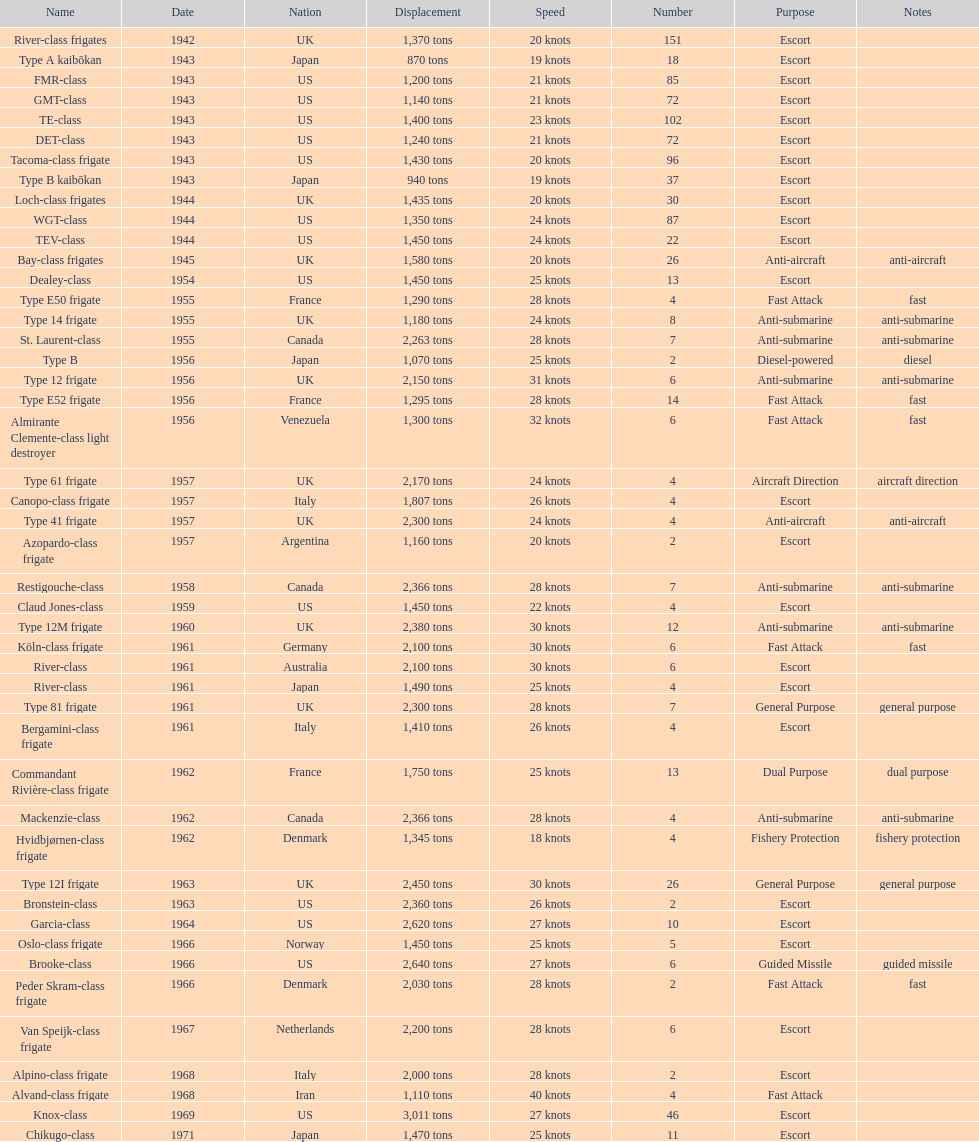What is the top speed? 40 knots. Give me the full table as a dictionary. {'header': ['Name', 'Date', 'Nation', 'Displacement', 'Speed', 'Number', 'Purpose', 'Notes'], 'rows': [['River-class frigates', '1942', 'UK', '1,370 tons', '20 knots', '151', 'Escort', ''], ['Type A kaibōkan', '1943', 'Japan', '870 tons', '19 knots', '18', 'Escort', ''], ['FMR-class', '1943', 'US', '1,200 tons', '21 knots', '85', 'Escort', ''], ['GMT-class', '1943', 'US', '1,140 tons', '21 knots', '72', 'Escort', ''], ['TE-class', '1943', 'US', '1,400 tons', '23 knots', '102', 'Escort', ''], ['DET-class', '1943', 'US', '1,240 tons', '21 knots', '72', 'Escort', ''], ['Tacoma-class frigate', '1943', 'US', '1,430 tons', '20 knots', '96', 'Escort', ''], ['Type B kaibōkan', '1943', 'Japan', '940 tons', '19 knots', '37', 'Escort', ''], ['Loch-class frigates', '1944', 'UK', '1,435 tons', '20 knots', '30', 'Escort', ''], ['WGT-class', '1944', 'US', '1,350 tons', '24 knots', '87', 'Escort', ''], ['TEV-class', '1944', 'US', '1,450 tons', '24 knots', '22', 'Escort', ''], ['Bay-class frigates', '1945', 'UK', '1,580 tons', '20 knots', '26', 'Anti-aircraft', 'anti-aircraft'], ['Dealey-class', '1954', 'US', '1,450 tons', '25 knots', '13', 'Escort', ''], ['Type E50 frigate', '1955', 'France', '1,290 tons', '28 knots', '4', 'Fast Attack', 'fast'], ['Type 14 frigate', '1955', 'UK', '1,180 tons', '24 knots', '8', 'Anti-submarine', 'anti-submarine'], ['St. Laurent-class', '1955', 'Canada', '2,263 tons', '28 knots', '7', 'Anti-submarine', 'anti-submarine'], ['Type B', '1956', 'Japan', '1,070 tons', '25 knots', '2', 'Diesel-powered', 'diesel'], ['Type 12 frigate', '1956', 'UK', '2,150 tons', '31 knots', '6', 'Anti-submarine', 'anti-submarine'], ['Type E52 frigate', '1956', 'France', '1,295 tons', '28 knots', '14', 'Fast Attack', 'fast'], ['Almirante Clemente-class light destroyer', '1956', 'Venezuela', '1,300 tons', '32 knots', '6', 'Fast Attack', 'fast'], ['Type 61 frigate', '1957', 'UK', '2,170 tons', '24 knots', '4', 'Aircraft Direction', 'aircraft direction'], ['Canopo-class frigate', '1957', 'Italy', '1,807 tons', '26 knots', '4', 'Escort', ''], ['Type 41 frigate', '1957', 'UK', '2,300 tons', '24 knots', '4', 'Anti-aircraft', 'anti-aircraft'], ['Azopardo-class frigate', '1957', 'Argentina', '1,160 tons', '20 knots', '2', 'Escort', ''], ['Restigouche-class', '1958', 'Canada', '2,366 tons', '28 knots', '7', 'Anti-submarine', 'anti-submarine'], ['Claud Jones-class', '1959', 'US', '1,450 tons', '22 knots', '4', 'Escort', ''], ['Type 12M frigate', '1960', 'UK', '2,380 tons', '30 knots', '12', 'Anti-submarine', 'anti-submarine'], ['Köln-class frigate', '1961', 'Germany', '2,100 tons', '30 knots', '6', 'Fast Attack', 'fast'], ['River-class', '1961', 'Australia', '2,100 tons', '30 knots', '6', 'Escort', ''], ['River-class', '1961', 'Japan', '1,490 tons', '25 knots', '4', 'Escort', ''], ['Type 81 frigate', '1961', 'UK', '2,300 tons', '28 knots', '7', 'General Purpose', 'general purpose'], ['Bergamini-class frigate', '1961', 'Italy', '1,410 tons', '26 knots', '4', 'Escort', ''], ['Commandant Rivière-class frigate', '1962', 'France', '1,750 tons', '25 knots', '13', 'Dual Purpose', 'dual purpose'], ['Mackenzie-class', '1962', 'Canada', '2,366 tons', '28 knots', '4', 'Anti-submarine', 'anti-submarine'], ['Hvidbjørnen-class frigate', '1962', 'Denmark', '1,345 tons', '18 knots', '4', 'Fishery Protection', 'fishery protection'], ['Type 12I frigate', '1963', 'UK', '2,450 tons', '30 knots', '26', 'General Purpose', 'general purpose'], ['Bronstein-class', '1963', 'US', '2,360 tons', '26 knots', '2', 'Escort', ''], ['Garcia-class', '1964', 'US', '2,620 tons', '27 knots', '10', 'Escort', ''], ['Oslo-class frigate', '1966', 'Norway', '1,450 tons', '25 knots', '5', 'Escort', ''], ['Brooke-class', '1966', 'US', '2,640 tons', '27 knots', '6', 'Guided Missile', 'guided missile'], ['Peder Skram-class frigate', '1966', 'Denmark', '2,030 tons', '28 knots', '2', 'Fast Attack', 'fast'], ['Van Speijk-class frigate', '1967', 'Netherlands', '2,200 tons', '28 knots', '6', 'Escort', ''], ['Alpino-class frigate', '1968', 'Italy', '2,000 tons', '28 knots', '2', 'Escort', ''], ['Alvand-class frigate', '1968', 'Iran', '1,110 tons', '40 knots', '4', 'Fast Attack', ''], ['Knox-class', '1969', 'US', '3,011 tons', '27 knots', '46', 'Escort', ''], ['Chikugo-class', '1971', 'Japan', '1,470 tons', '25 knots', '11', 'Escort', '']]} 